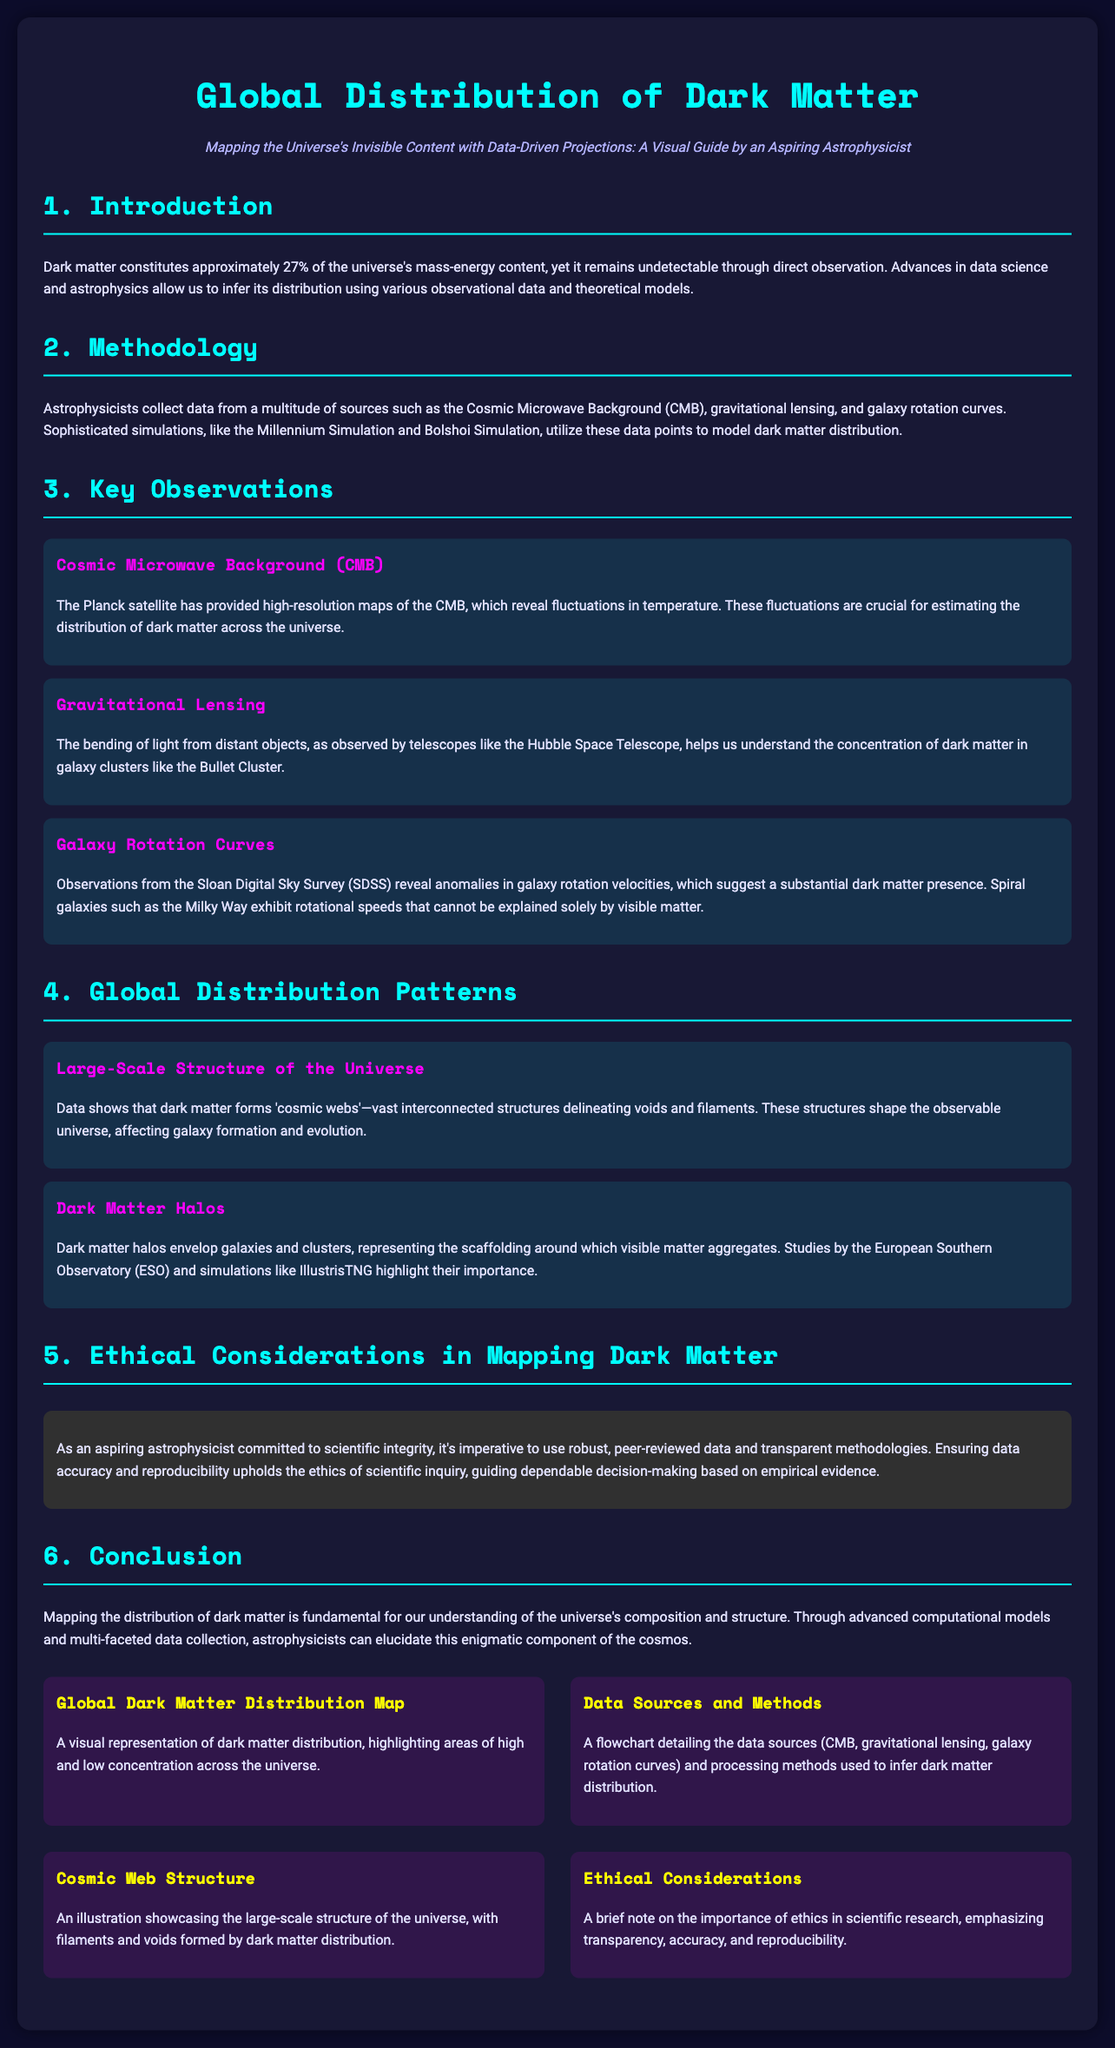what percentage of the universe's mass-energy content is dark matter? The document states that dark matter constitutes approximately 27% of the universe's mass-energy content.
Answer: 27% which satellite provided high-resolution maps of the Cosmic Microwave Background? The Planck satellite provided high-resolution maps that are crucial for estimating dark matter distribution.
Answer: Planck what phenomenon helps understand the concentration of dark matter in galaxy clusters? The bending of light from distant objects, also known as gravitational lensing, helps understand dark matter concentration.
Answer: Gravitational lensing which survey revealed anomalies in galaxy rotation velocities? Observations from the Sloan Digital Sky Survey (SDSS) revealed these anomalies indicating dark matter presence.
Answer: Sloan Digital Sky Survey what shapes the observable universe according to the document? The document mentions that the 'cosmic webs' formed by dark matter shape the observable universe.
Answer: Cosmic webs what is the importance of robust, peer-reviewed data in scientific inquiry? It ensures data accuracy and reproducibility, which upholds the ethics of scientific inquiry.
Answer: Data accuracy and reproducibility what type of visual representation is included in the infographic? The infographic includes a global dark matter distribution map highlighting areas of high and low concentration.
Answer: Global dark matter distribution map which observational data sources are mentioned for inferring dark matter distribution? The document lists Cosmic Microwave Background, gravitational lensing, and galaxy rotation curves as data sources.
Answer: Cosmic Microwave Background, gravitational lensing, galaxy rotation curves what does the illustration in the infographic showcase? The illustration showcases the large-scale structure of the universe with filaments and voids formed by dark matter.
Answer: Large-scale structure of the universe 